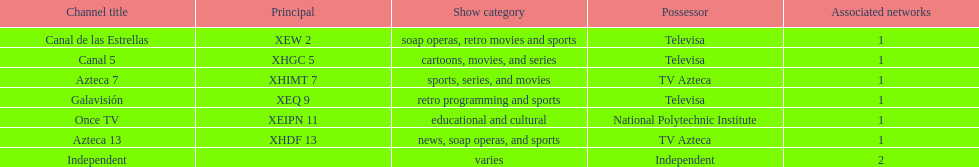What is the number of networks that are owned by televisa? 3. 